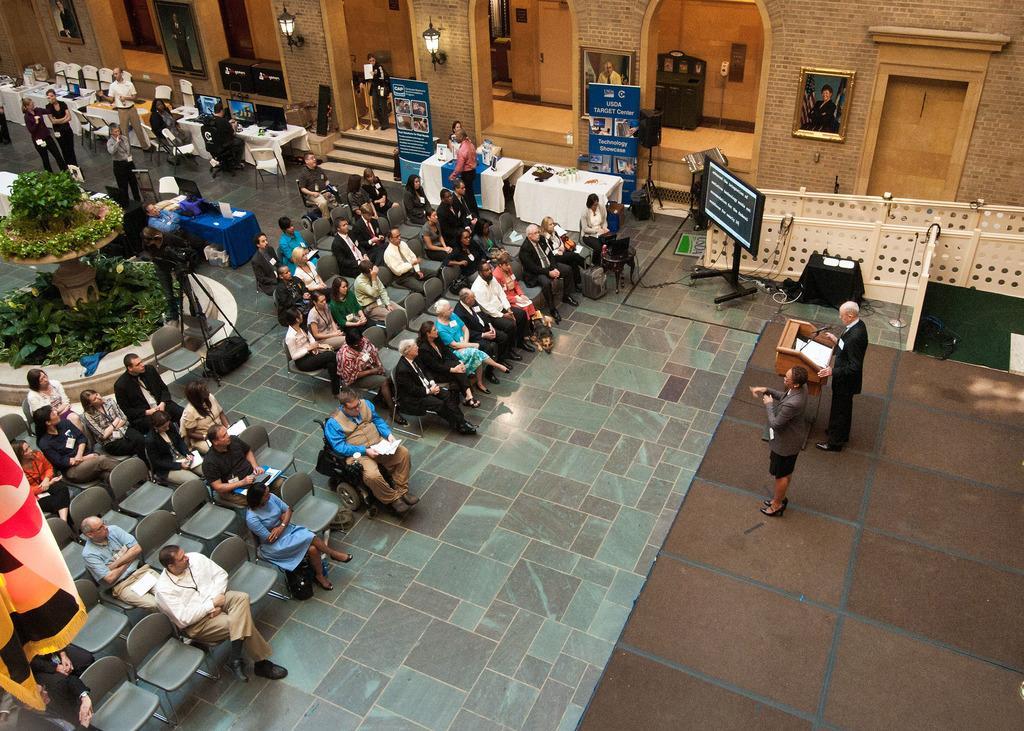Could you give a brief overview of what you see in this image? In the image in the center, we can see a group of people were sitting on the chairs. And we can see tables, chairs, banners, flags, plants and a few other objects. On the left side, we can see two persons were standing. In front of them, there is a wooden stand, microphone and books. In the background there is a wall, staircase, doors, photo frames, lamps, cupboards and a few other objects. 